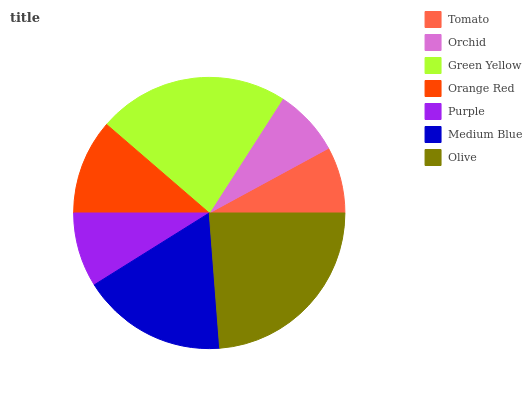Is Tomato the minimum?
Answer yes or no. Yes. Is Olive the maximum?
Answer yes or no. Yes. Is Orchid the minimum?
Answer yes or no. No. Is Orchid the maximum?
Answer yes or no. No. Is Orchid greater than Tomato?
Answer yes or no. Yes. Is Tomato less than Orchid?
Answer yes or no. Yes. Is Tomato greater than Orchid?
Answer yes or no. No. Is Orchid less than Tomato?
Answer yes or no. No. Is Orange Red the high median?
Answer yes or no. Yes. Is Orange Red the low median?
Answer yes or no. Yes. Is Purple the high median?
Answer yes or no. No. Is Purple the low median?
Answer yes or no. No. 